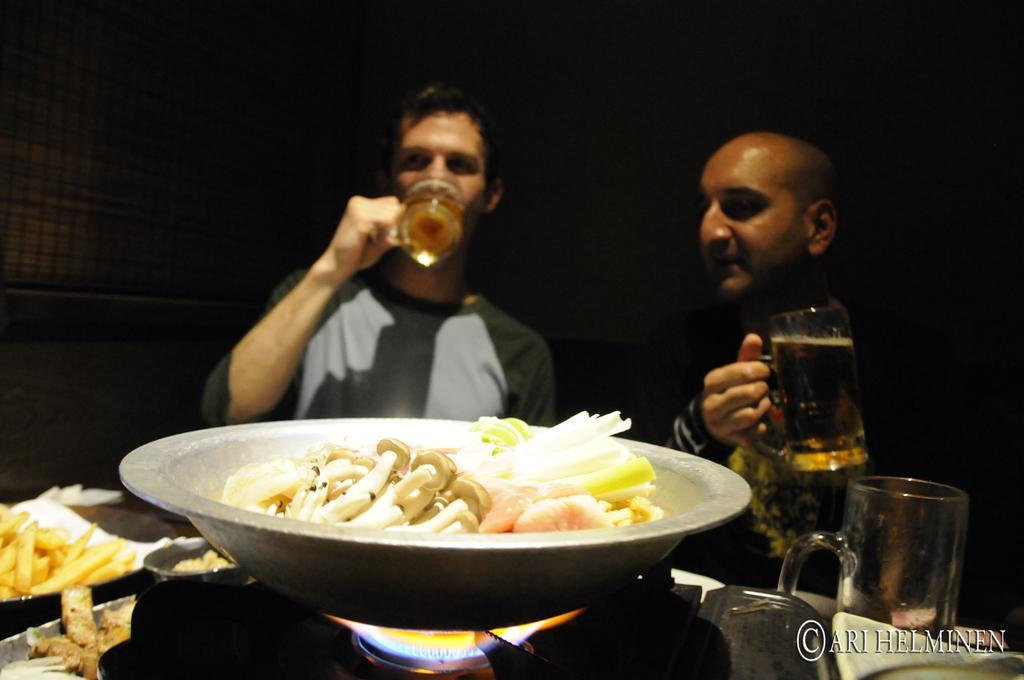Describe this image in one or two sentences. This is the picture of two people who are holding the glass in which there is some juice and in front of them there is a vessel on the stove in which there is some food item and to the side there are some fries and a glass. 